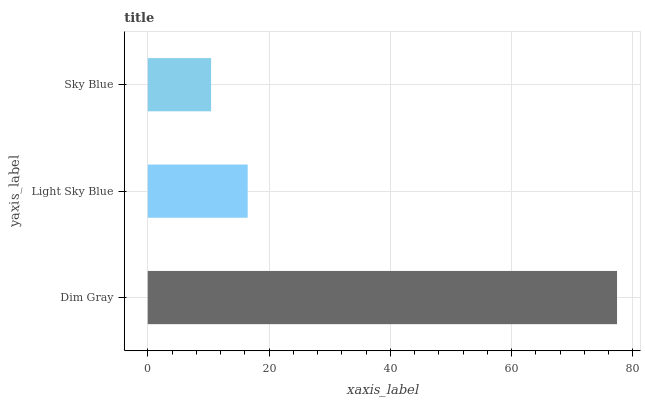Is Sky Blue the minimum?
Answer yes or no. Yes. Is Dim Gray the maximum?
Answer yes or no. Yes. Is Light Sky Blue the minimum?
Answer yes or no. No. Is Light Sky Blue the maximum?
Answer yes or no. No. Is Dim Gray greater than Light Sky Blue?
Answer yes or no. Yes. Is Light Sky Blue less than Dim Gray?
Answer yes or no. Yes. Is Light Sky Blue greater than Dim Gray?
Answer yes or no. No. Is Dim Gray less than Light Sky Blue?
Answer yes or no. No. Is Light Sky Blue the high median?
Answer yes or no. Yes. Is Light Sky Blue the low median?
Answer yes or no. Yes. Is Sky Blue the high median?
Answer yes or no. No. Is Dim Gray the low median?
Answer yes or no. No. 